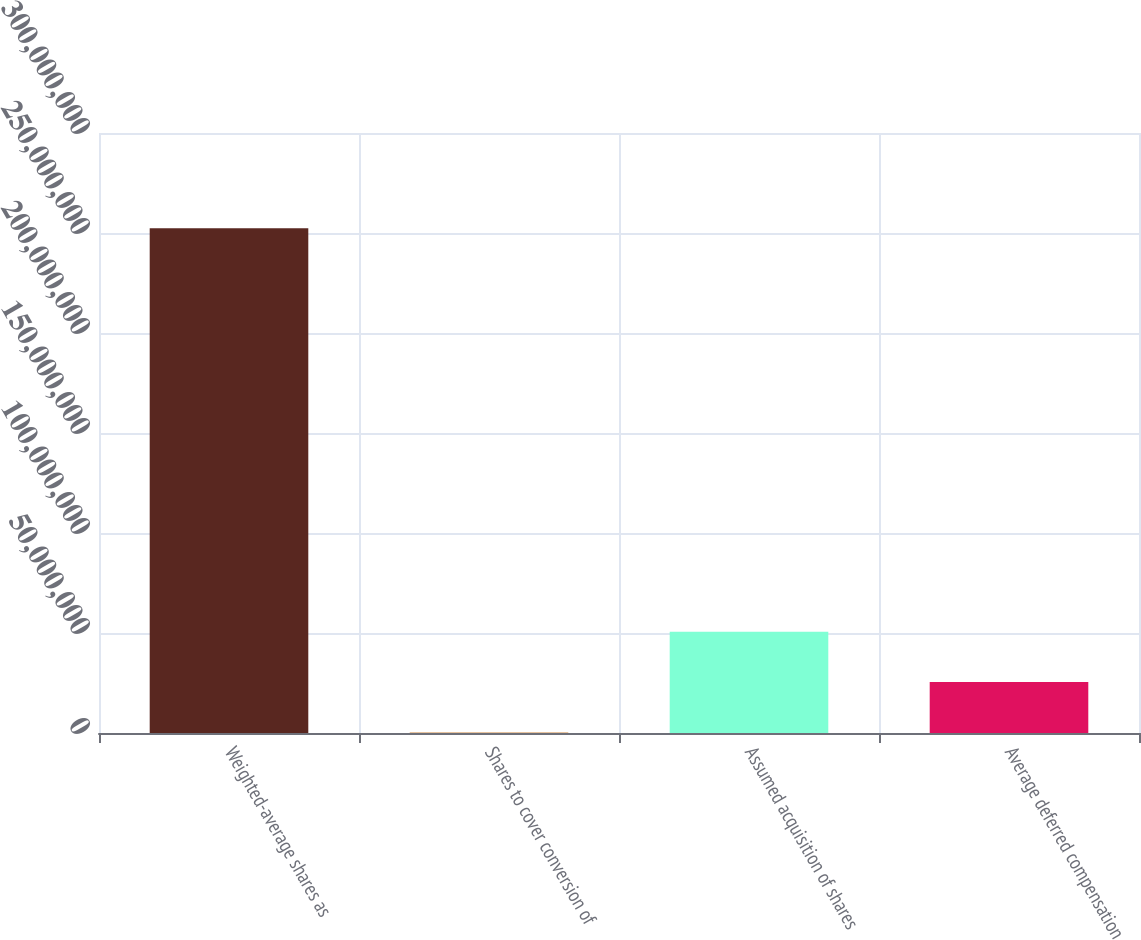Convert chart. <chart><loc_0><loc_0><loc_500><loc_500><bar_chart><fcel>Weighted-average shares as<fcel>Shares to cover conversion of<fcel>Assumed acquisition of shares<fcel>Average deferred compensation<nl><fcel>2.52363e+08<fcel>229113<fcel>5.06559e+07<fcel>2.54425e+07<nl></chart> 